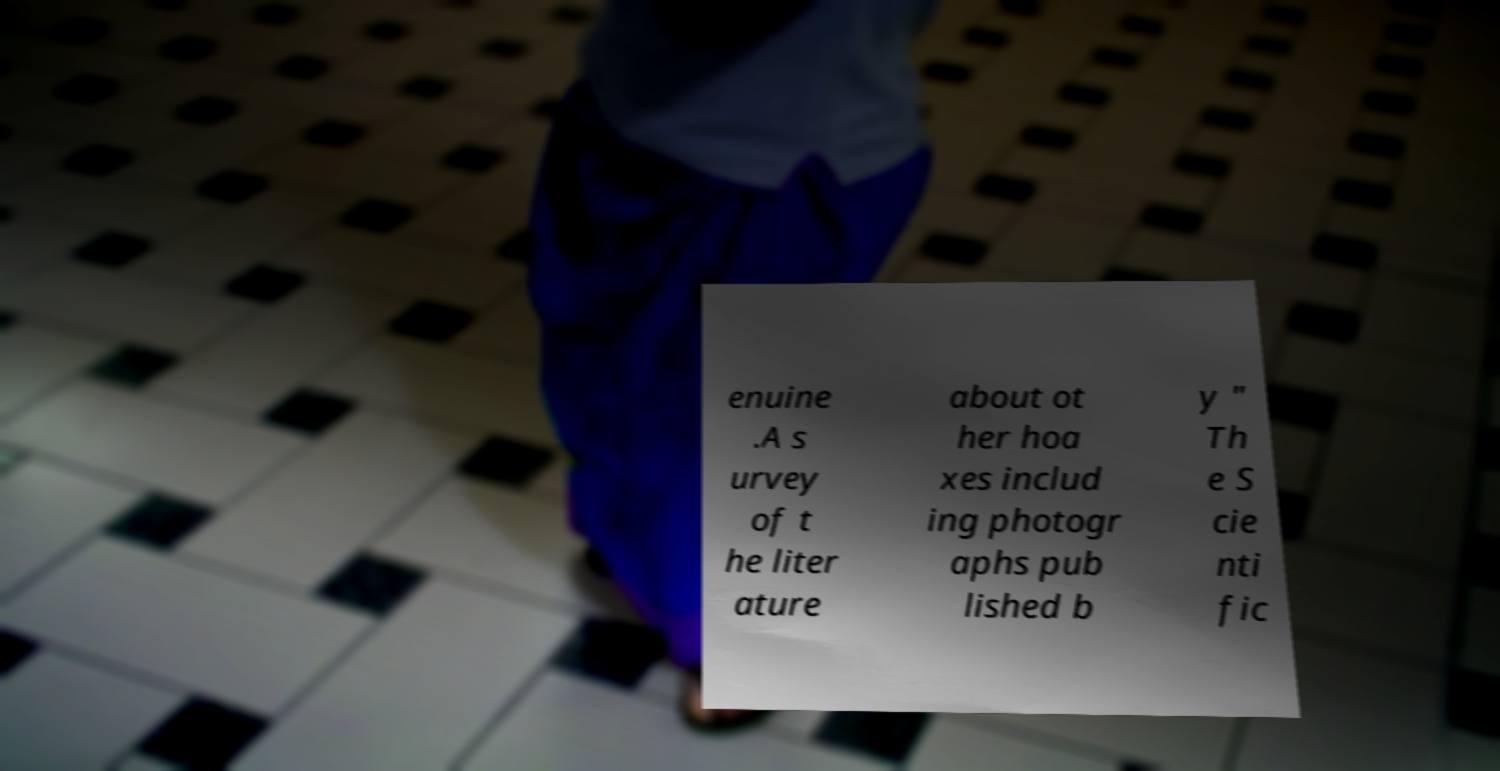Please read and relay the text visible in this image. What does it say? enuine .A s urvey of t he liter ature about ot her hoa xes includ ing photogr aphs pub lished b y " Th e S cie nti fic 